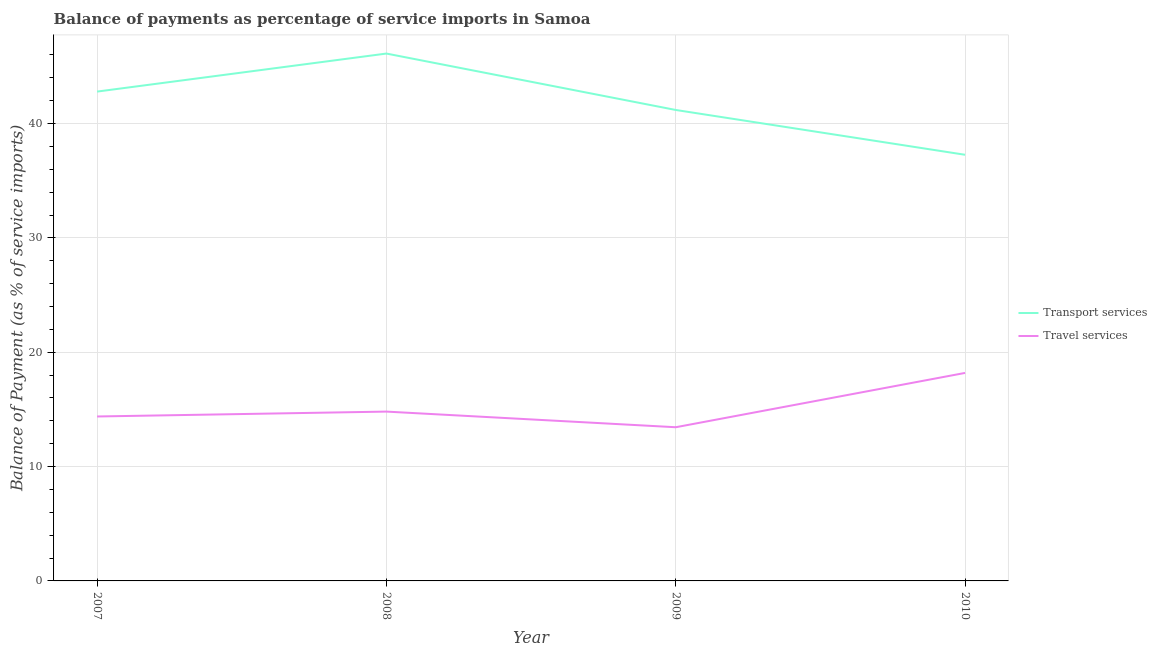How many different coloured lines are there?
Make the answer very short. 2. Is the number of lines equal to the number of legend labels?
Offer a terse response. Yes. What is the balance of payments of transport services in 2008?
Provide a short and direct response. 46.12. Across all years, what is the maximum balance of payments of travel services?
Ensure brevity in your answer.  18.19. Across all years, what is the minimum balance of payments of transport services?
Offer a terse response. 37.27. In which year was the balance of payments of transport services maximum?
Keep it short and to the point. 2008. In which year was the balance of payments of transport services minimum?
Your answer should be compact. 2010. What is the total balance of payments of transport services in the graph?
Offer a terse response. 167.38. What is the difference between the balance of payments of travel services in 2007 and that in 2008?
Your response must be concise. -0.43. What is the difference between the balance of payments of travel services in 2010 and the balance of payments of transport services in 2008?
Offer a very short reply. -27.93. What is the average balance of payments of travel services per year?
Offer a terse response. 15.21. In the year 2009, what is the difference between the balance of payments of travel services and balance of payments of transport services?
Provide a succinct answer. -27.75. What is the ratio of the balance of payments of transport services in 2009 to that in 2010?
Keep it short and to the point. 1.11. Is the difference between the balance of payments of transport services in 2007 and 2008 greater than the difference between the balance of payments of travel services in 2007 and 2008?
Keep it short and to the point. No. What is the difference between the highest and the second highest balance of payments of travel services?
Your response must be concise. 3.38. What is the difference between the highest and the lowest balance of payments of transport services?
Your answer should be very brief. 8.85. Does the balance of payments of transport services monotonically increase over the years?
Offer a terse response. No. Is the balance of payments of transport services strictly greater than the balance of payments of travel services over the years?
Your answer should be compact. Yes. Is the balance of payments of travel services strictly less than the balance of payments of transport services over the years?
Provide a succinct answer. Yes. How many years are there in the graph?
Provide a short and direct response. 4. Does the graph contain any zero values?
Your answer should be compact. No. Where does the legend appear in the graph?
Offer a terse response. Center right. How are the legend labels stacked?
Make the answer very short. Vertical. What is the title of the graph?
Make the answer very short. Balance of payments as percentage of service imports in Samoa. Does "Study and work" appear as one of the legend labels in the graph?
Your response must be concise. No. What is the label or title of the X-axis?
Offer a terse response. Year. What is the label or title of the Y-axis?
Ensure brevity in your answer.  Balance of Payment (as % of service imports). What is the Balance of Payment (as % of service imports) in Transport services in 2007?
Offer a very short reply. 42.8. What is the Balance of Payment (as % of service imports) of Travel services in 2007?
Offer a very short reply. 14.38. What is the Balance of Payment (as % of service imports) of Transport services in 2008?
Make the answer very short. 46.12. What is the Balance of Payment (as % of service imports) in Travel services in 2008?
Offer a terse response. 14.81. What is the Balance of Payment (as % of service imports) of Transport services in 2009?
Make the answer very short. 41.19. What is the Balance of Payment (as % of service imports) in Travel services in 2009?
Offer a terse response. 13.44. What is the Balance of Payment (as % of service imports) in Transport services in 2010?
Keep it short and to the point. 37.27. What is the Balance of Payment (as % of service imports) of Travel services in 2010?
Keep it short and to the point. 18.19. Across all years, what is the maximum Balance of Payment (as % of service imports) in Transport services?
Keep it short and to the point. 46.12. Across all years, what is the maximum Balance of Payment (as % of service imports) in Travel services?
Your answer should be very brief. 18.19. Across all years, what is the minimum Balance of Payment (as % of service imports) in Transport services?
Provide a short and direct response. 37.27. Across all years, what is the minimum Balance of Payment (as % of service imports) in Travel services?
Provide a short and direct response. 13.44. What is the total Balance of Payment (as % of service imports) in Transport services in the graph?
Provide a short and direct response. 167.38. What is the total Balance of Payment (as % of service imports) in Travel services in the graph?
Offer a terse response. 60.82. What is the difference between the Balance of Payment (as % of service imports) of Transport services in 2007 and that in 2008?
Make the answer very short. -3.33. What is the difference between the Balance of Payment (as % of service imports) in Travel services in 2007 and that in 2008?
Ensure brevity in your answer.  -0.43. What is the difference between the Balance of Payment (as % of service imports) in Transport services in 2007 and that in 2009?
Make the answer very short. 1.61. What is the difference between the Balance of Payment (as % of service imports) of Travel services in 2007 and that in 2009?
Provide a succinct answer. 0.94. What is the difference between the Balance of Payment (as % of service imports) of Transport services in 2007 and that in 2010?
Provide a short and direct response. 5.53. What is the difference between the Balance of Payment (as % of service imports) of Travel services in 2007 and that in 2010?
Ensure brevity in your answer.  -3.81. What is the difference between the Balance of Payment (as % of service imports) of Transport services in 2008 and that in 2009?
Offer a terse response. 4.93. What is the difference between the Balance of Payment (as % of service imports) of Travel services in 2008 and that in 2009?
Provide a short and direct response. 1.37. What is the difference between the Balance of Payment (as % of service imports) of Transport services in 2008 and that in 2010?
Ensure brevity in your answer.  8.85. What is the difference between the Balance of Payment (as % of service imports) of Travel services in 2008 and that in 2010?
Keep it short and to the point. -3.38. What is the difference between the Balance of Payment (as % of service imports) of Transport services in 2009 and that in 2010?
Provide a short and direct response. 3.92. What is the difference between the Balance of Payment (as % of service imports) in Travel services in 2009 and that in 2010?
Ensure brevity in your answer.  -4.75. What is the difference between the Balance of Payment (as % of service imports) in Transport services in 2007 and the Balance of Payment (as % of service imports) in Travel services in 2008?
Provide a succinct answer. 27.99. What is the difference between the Balance of Payment (as % of service imports) in Transport services in 2007 and the Balance of Payment (as % of service imports) in Travel services in 2009?
Your answer should be compact. 29.36. What is the difference between the Balance of Payment (as % of service imports) in Transport services in 2007 and the Balance of Payment (as % of service imports) in Travel services in 2010?
Offer a very short reply. 24.6. What is the difference between the Balance of Payment (as % of service imports) in Transport services in 2008 and the Balance of Payment (as % of service imports) in Travel services in 2009?
Offer a terse response. 32.68. What is the difference between the Balance of Payment (as % of service imports) in Transport services in 2008 and the Balance of Payment (as % of service imports) in Travel services in 2010?
Keep it short and to the point. 27.93. What is the difference between the Balance of Payment (as % of service imports) of Transport services in 2009 and the Balance of Payment (as % of service imports) of Travel services in 2010?
Ensure brevity in your answer.  23. What is the average Balance of Payment (as % of service imports) of Transport services per year?
Provide a succinct answer. 41.84. What is the average Balance of Payment (as % of service imports) of Travel services per year?
Your answer should be very brief. 15.21. In the year 2007, what is the difference between the Balance of Payment (as % of service imports) of Transport services and Balance of Payment (as % of service imports) of Travel services?
Offer a very short reply. 28.42. In the year 2008, what is the difference between the Balance of Payment (as % of service imports) of Transport services and Balance of Payment (as % of service imports) of Travel services?
Ensure brevity in your answer.  31.31. In the year 2009, what is the difference between the Balance of Payment (as % of service imports) of Transport services and Balance of Payment (as % of service imports) of Travel services?
Your answer should be compact. 27.75. In the year 2010, what is the difference between the Balance of Payment (as % of service imports) of Transport services and Balance of Payment (as % of service imports) of Travel services?
Make the answer very short. 19.08. What is the ratio of the Balance of Payment (as % of service imports) in Transport services in 2007 to that in 2008?
Give a very brief answer. 0.93. What is the ratio of the Balance of Payment (as % of service imports) in Travel services in 2007 to that in 2008?
Offer a very short reply. 0.97. What is the ratio of the Balance of Payment (as % of service imports) in Transport services in 2007 to that in 2009?
Make the answer very short. 1.04. What is the ratio of the Balance of Payment (as % of service imports) of Travel services in 2007 to that in 2009?
Your response must be concise. 1.07. What is the ratio of the Balance of Payment (as % of service imports) in Transport services in 2007 to that in 2010?
Your answer should be compact. 1.15. What is the ratio of the Balance of Payment (as % of service imports) of Travel services in 2007 to that in 2010?
Your answer should be very brief. 0.79. What is the ratio of the Balance of Payment (as % of service imports) of Transport services in 2008 to that in 2009?
Your response must be concise. 1.12. What is the ratio of the Balance of Payment (as % of service imports) of Travel services in 2008 to that in 2009?
Offer a terse response. 1.1. What is the ratio of the Balance of Payment (as % of service imports) of Transport services in 2008 to that in 2010?
Give a very brief answer. 1.24. What is the ratio of the Balance of Payment (as % of service imports) in Travel services in 2008 to that in 2010?
Make the answer very short. 0.81. What is the ratio of the Balance of Payment (as % of service imports) of Transport services in 2009 to that in 2010?
Offer a terse response. 1.11. What is the ratio of the Balance of Payment (as % of service imports) in Travel services in 2009 to that in 2010?
Offer a terse response. 0.74. What is the difference between the highest and the second highest Balance of Payment (as % of service imports) in Transport services?
Offer a very short reply. 3.33. What is the difference between the highest and the second highest Balance of Payment (as % of service imports) of Travel services?
Provide a succinct answer. 3.38. What is the difference between the highest and the lowest Balance of Payment (as % of service imports) of Transport services?
Your response must be concise. 8.85. What is the difference between the highest and the lowest Balance of Payment (as % of service imports) in Travel services?
Provide a short and direct response. 4.75. 